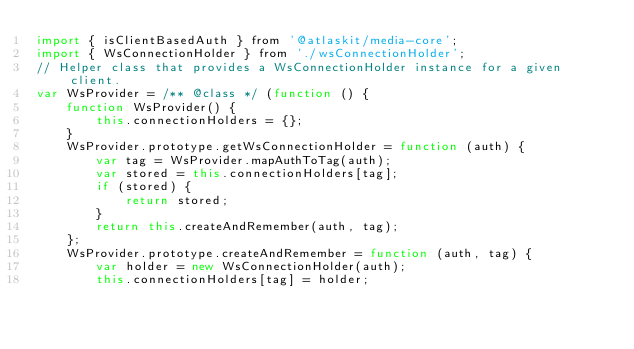Convert code to text. <code><loc_0><loc_0><loc_500><loc_500><_JavaScript_>import { isClientBasedAuth } from '@atlaskit/media-core';
import { WsConnectionHolder } from './wsConnectionHolder';
// Helper class that provides a WsConnectionHolder instance for a given client.
var WsProvider = /** @class */ (function () {
    function WsProvider() {
        this.connectionHolders = {};
    }
    WsProvider.prototype.getWsConnectionHolder = function (auth) {
        var tag = WsProvider.mapAuthToTag(auth);
        var stored = this.connectionHolders[tag];
        if (stored) {
            return stored;
        }
        return this.createAndRemember(auth, tag);
    };
    WsProvider.prototype.createAndRemember = function (auth, tag) {
        var holder = new WsConnectionHolder(auth);
        this.connectionHolders[tag] = holder;</code> 